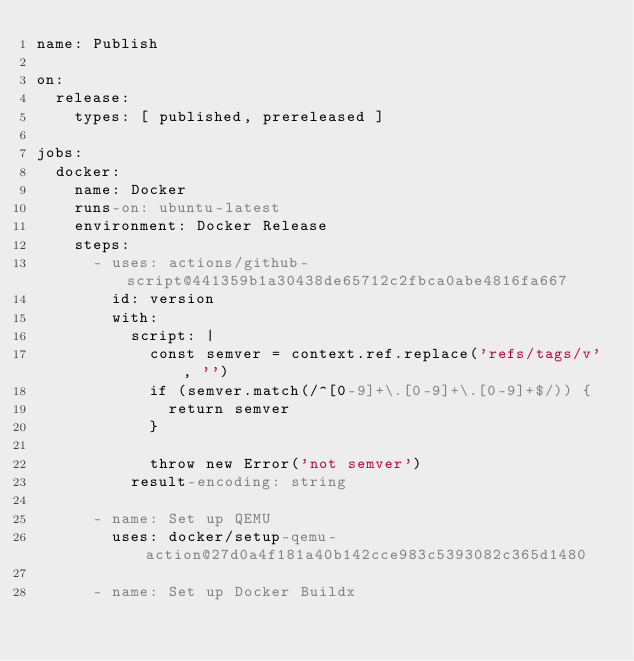Convert code to text. <code><loc_0><loc_0><loc_500><loc_500><_YAML_>name: Publish

on:
  release:
    types: [ published, prereleased ]

jobs:
  docker:
    name: Docker
    runs-on: ubuntu-latest
    environment: Docker Release
    steps:
      - uses: actions/github-script@441359b1a30438de65712c2fbca0abe4816fa667
        id: version
        with:
          script: |
            const semver = context.ref.replace('refs/tags/v', '')
            if (semver.match(/^[0-9]+\.[0-9]+\.[0-9]+$/)) {
              return semver
            }

            throw new Error('not semver')
          result-encoding: string

      - name: Set up QEMU
        uses: docker/setup-qemu-action@27d0a4f181a40b142cce983c5393082c365d1480

      - name: Set up Docker Buildx</code> 